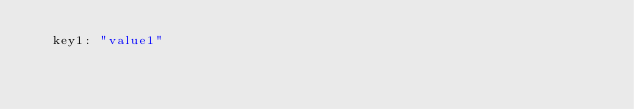<code> <loc_0><loc_0><loc_500><loc_500><_YAML_>  key1: "value1"
</code> 